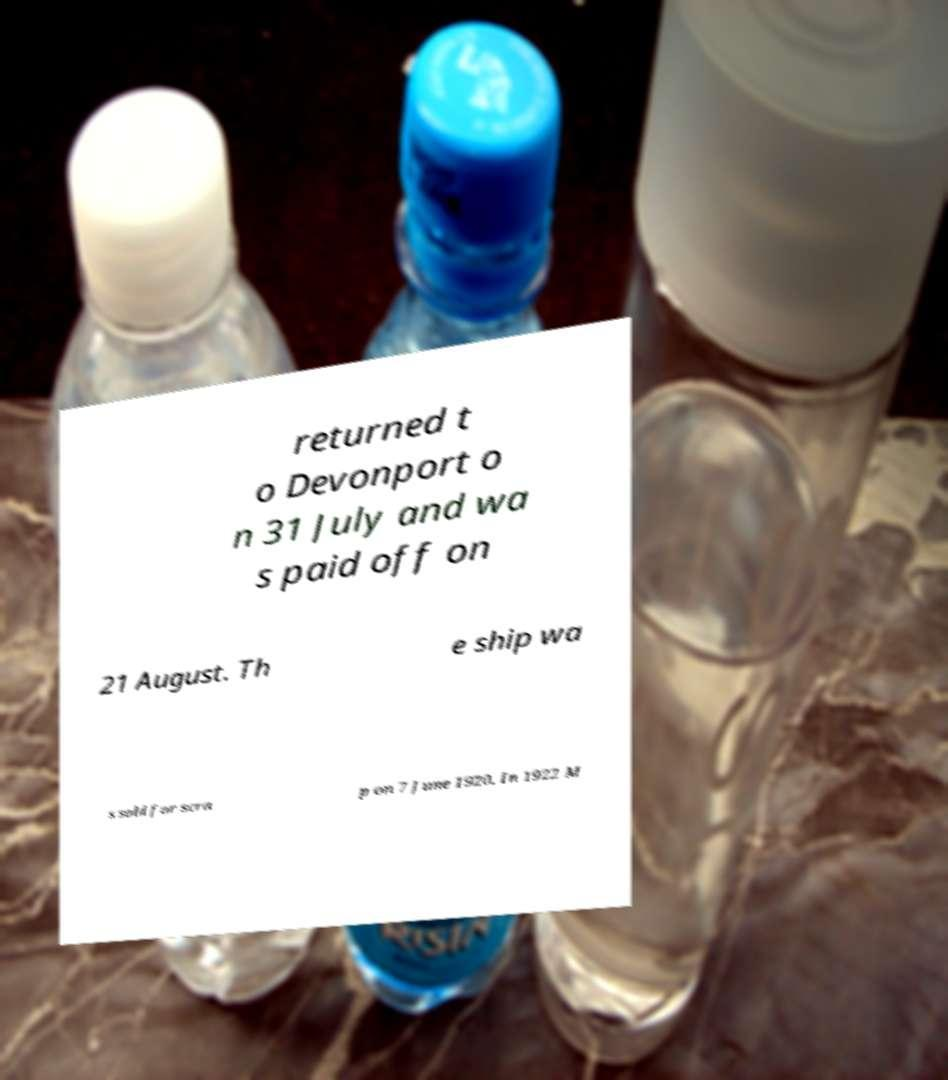Can you accurately transcribe the text from the provided image for me? returned t o Devonport o n 31 July and wa s paid off on 21 August. Th e ship wa s sold for scra p on 7 June 1920. In 1922 M 